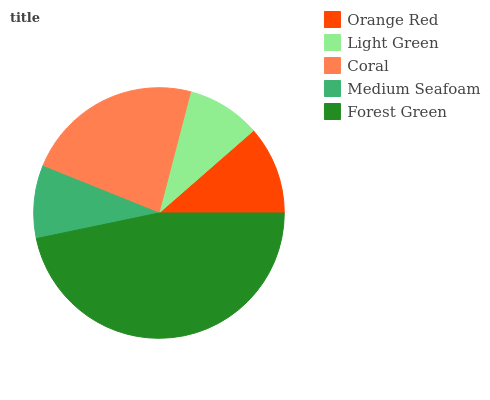Is Medium Seafoam the minimum?
Answer yes or no. Yes. Is Forest Green the maximum?
Answer yes or no. Yes. Is Light Green the minimum?
Answer yes or no. No. Is Light Green the maximum?
Answer yes or no. No. Is Orange Red greater than Light Green?
Answer yes or no. Yes. Is Light Green less than Orange Red?
Answer yes or no. Yes. Is Light Green greater than Orange Red?
Answer yes or no. No. Is Orange Red less than Light Green?
Answer yes or no. No. Is Orange Red the high median?
Answer yes or no. Yes. Is Orange Red the low median?
Answer yes or no. Yes. Is Light Green the high median?
Answer yes or no. No. Is Light Green the low median?
Answer yes or no. No. 